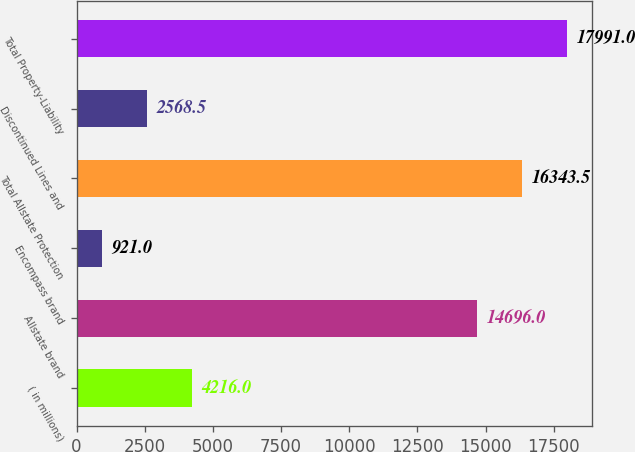Convert chart to OTSL. <chart><loc_0><loc_0><loc_500><loc_500><bar_chart><fcel>( in millions)<fcel>Allstate brand<fcel>Encompass brand<fcel>Total Allstate Protection<fcel>Discontinued Lines and<fcel>Total Property-Liability<nl><fcel>4216<fcel>14696<fcel>921<fcel>16343.5<fcel>2568.5<fcel>17991<nl></chart> 